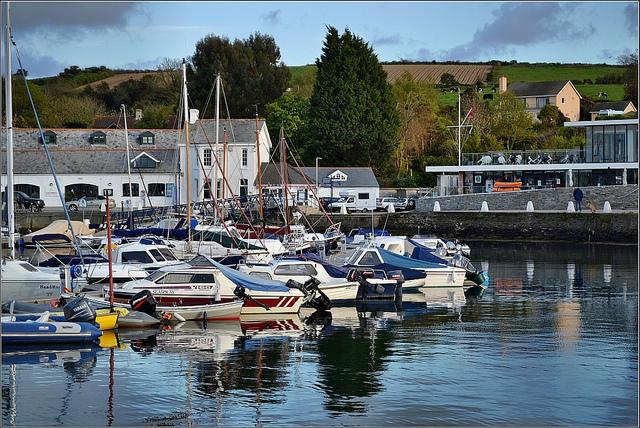Why is the hill above the sea brown with furrows?

Choices:
A) sports field
B) rodeo
C) farm land
D) housing development farm land 